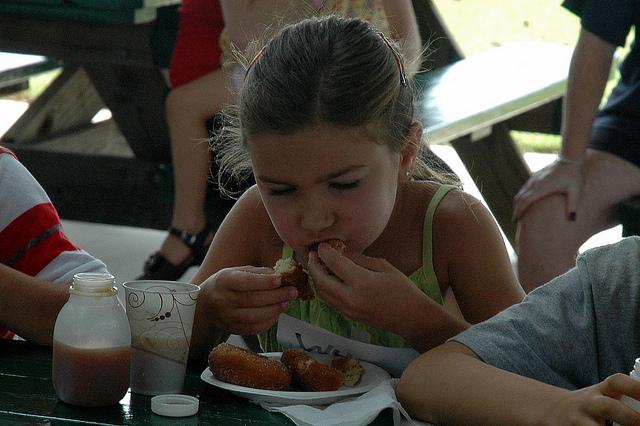Is the girl taking a nap?
Answer briefly. No. What is she holding?
Write a very short answer. Food. What color is the little girl's shirt?
Short answer required. Green. Are there toys on the floor?
Concise answer only. No. What is the person eating?
Be succinct. Donut. Which hand holds the next bite?
Answer briefly. Right. What is the girl eating?
Be succinct. Donut. What food is visible?
Write a very short answer. Donut. What is the girl eating with?
Write a very short answer. Hands. What kind of restaurant is this?
Give a very brief answer. Outdoor. Is the girl behind a gate?
Be succinct. No. What hairstyle does the little girl have?
Be succinct. Ponytail. Is the girl's hair color natural?
Keep it brief. Yes. What is the woman eating?
Keep it brief. Donut. 